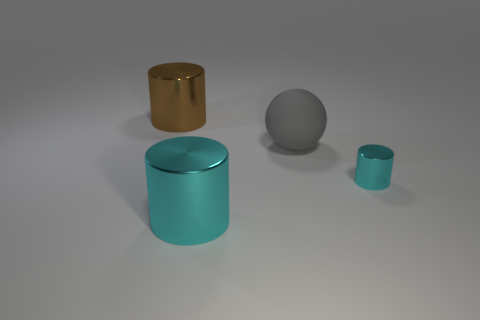Subtract all cyan cylinders. How many were subtracted if there are1cyan cylinders left? 1 Add 4 small metal cylinders. How many objects exist? 8 Subtract 0 blue cylinders. How many objects are left? 4 Subtract all balls. How many objects are left? 3 Subtract all big brown objects. Subtract all brown cylinders. How many objects are left? 2 Add 3 matte spheres. How many matte spheres are left? 4 Add 3 red matte spheres. How many red matte spheres exist? 3 